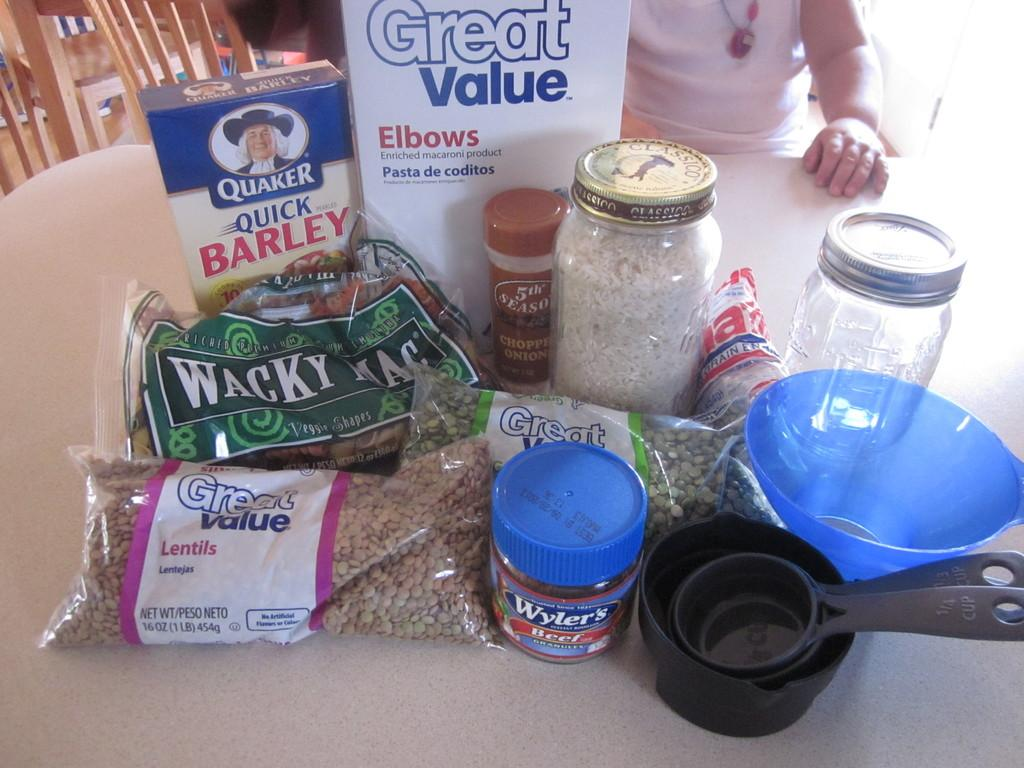<image>
Summarize the visual content of the image. Groceries on a table including Barley and Lentils. 